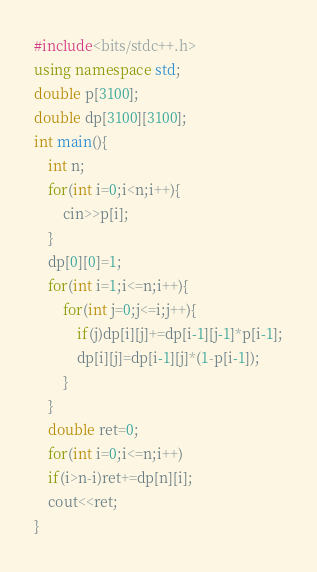Convert code to text. <code><loc_0><loc_0><loc_500><loc_500><_C++_>#include<bits/stdc++.h>
using namespace std;
double p[3100];
double dp[3100][3100];
int main(){
    int n;
    for(int i=0;i<n;i++){
        cin>>p[i];
    }
    dp[0][0]=1;
    for(int i=1;i<=n;i++){
        for(int j=0;j<=i;j++){
            if(j)dp[i][j]+=dp[i-1][j-1]*p[i-1];
            dp[i][j]=dp[i-1][j]*(1-p[i-1]);
        }
    }
    double ret=0;
    for(int i=0;i<=n;i++)
    if(i>n-i)ret+=dp[n][i];
    cout<<ret;
}
</code> 